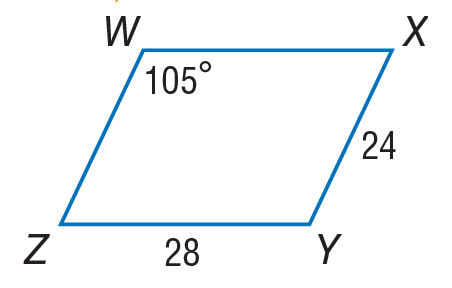Answer the mathemtical geometry problem and directly provide the correct option letter.
Question: Use parallelogram W X Y Z to find m \angle W Z Y.
Choices: A: 65 B: 75 C: 105 D: 180 B 